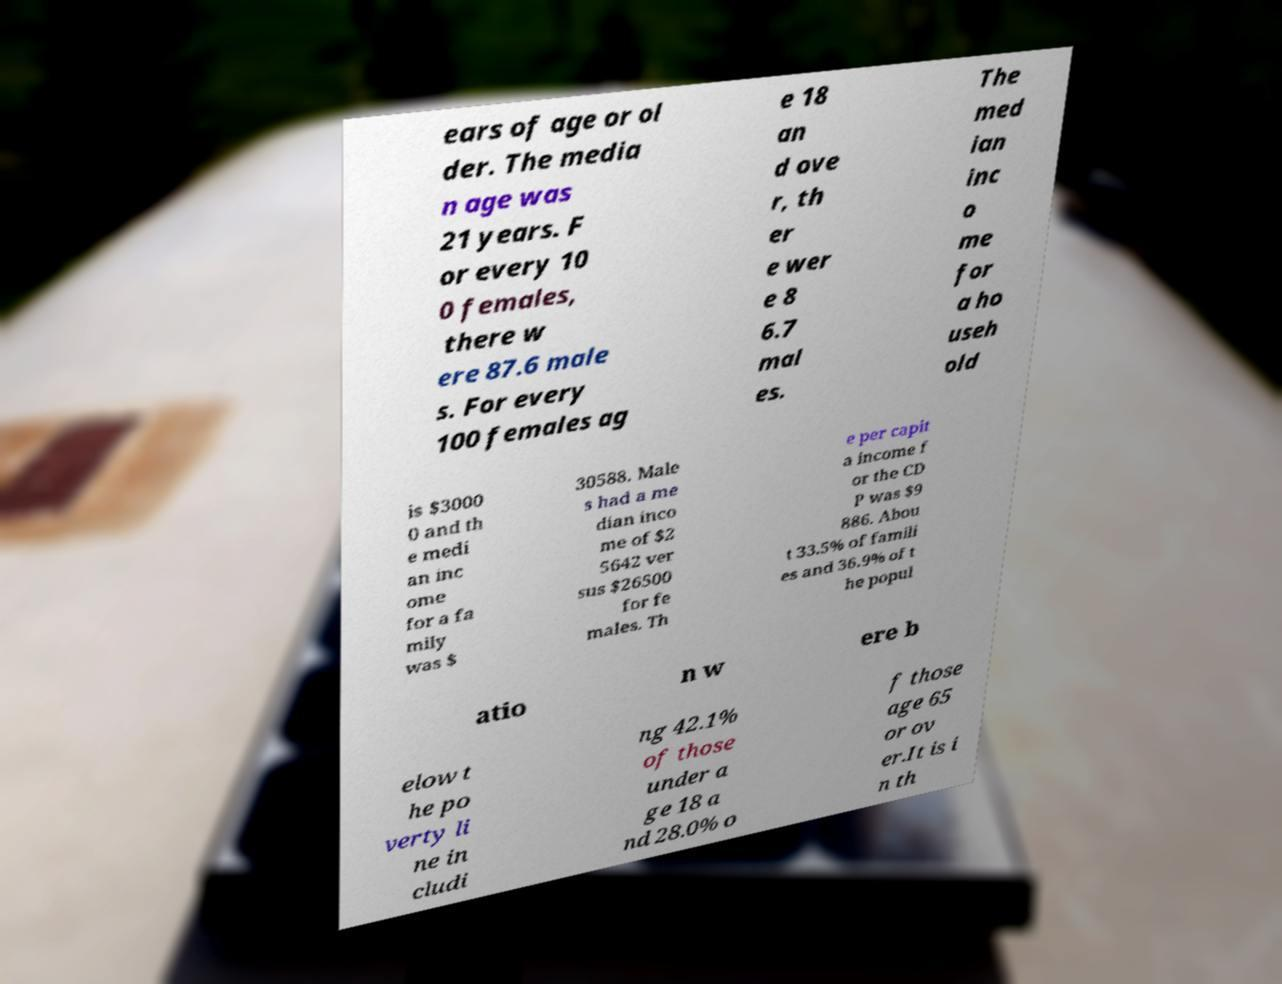Please read and relay the text visible in this image. What does it say? ears of age or ol der. The media n age was 21 years. F or every 10 0 females, there w ere 87.6 male s. For every 100 females ag e 18 an d ove r, th er e wer e 8 6.7 mal es. The med ian inc o me for a ho useh old is $3000 0 and th e medi an inc ome for a fa mily was $ 30588. Male s had a me dian inco me of $2 5642 ver sus $26500 for fe males. Th e per capit a income f or the CD P was $9 886. Abou t 33.5% of famili es and 36.9% of t he popul atio n w ere b elow t he po verty li ne in cludi ng 42.1% of those under a ge 18 a nd 28.0% o f those age 65 or ov er.It is i n th 